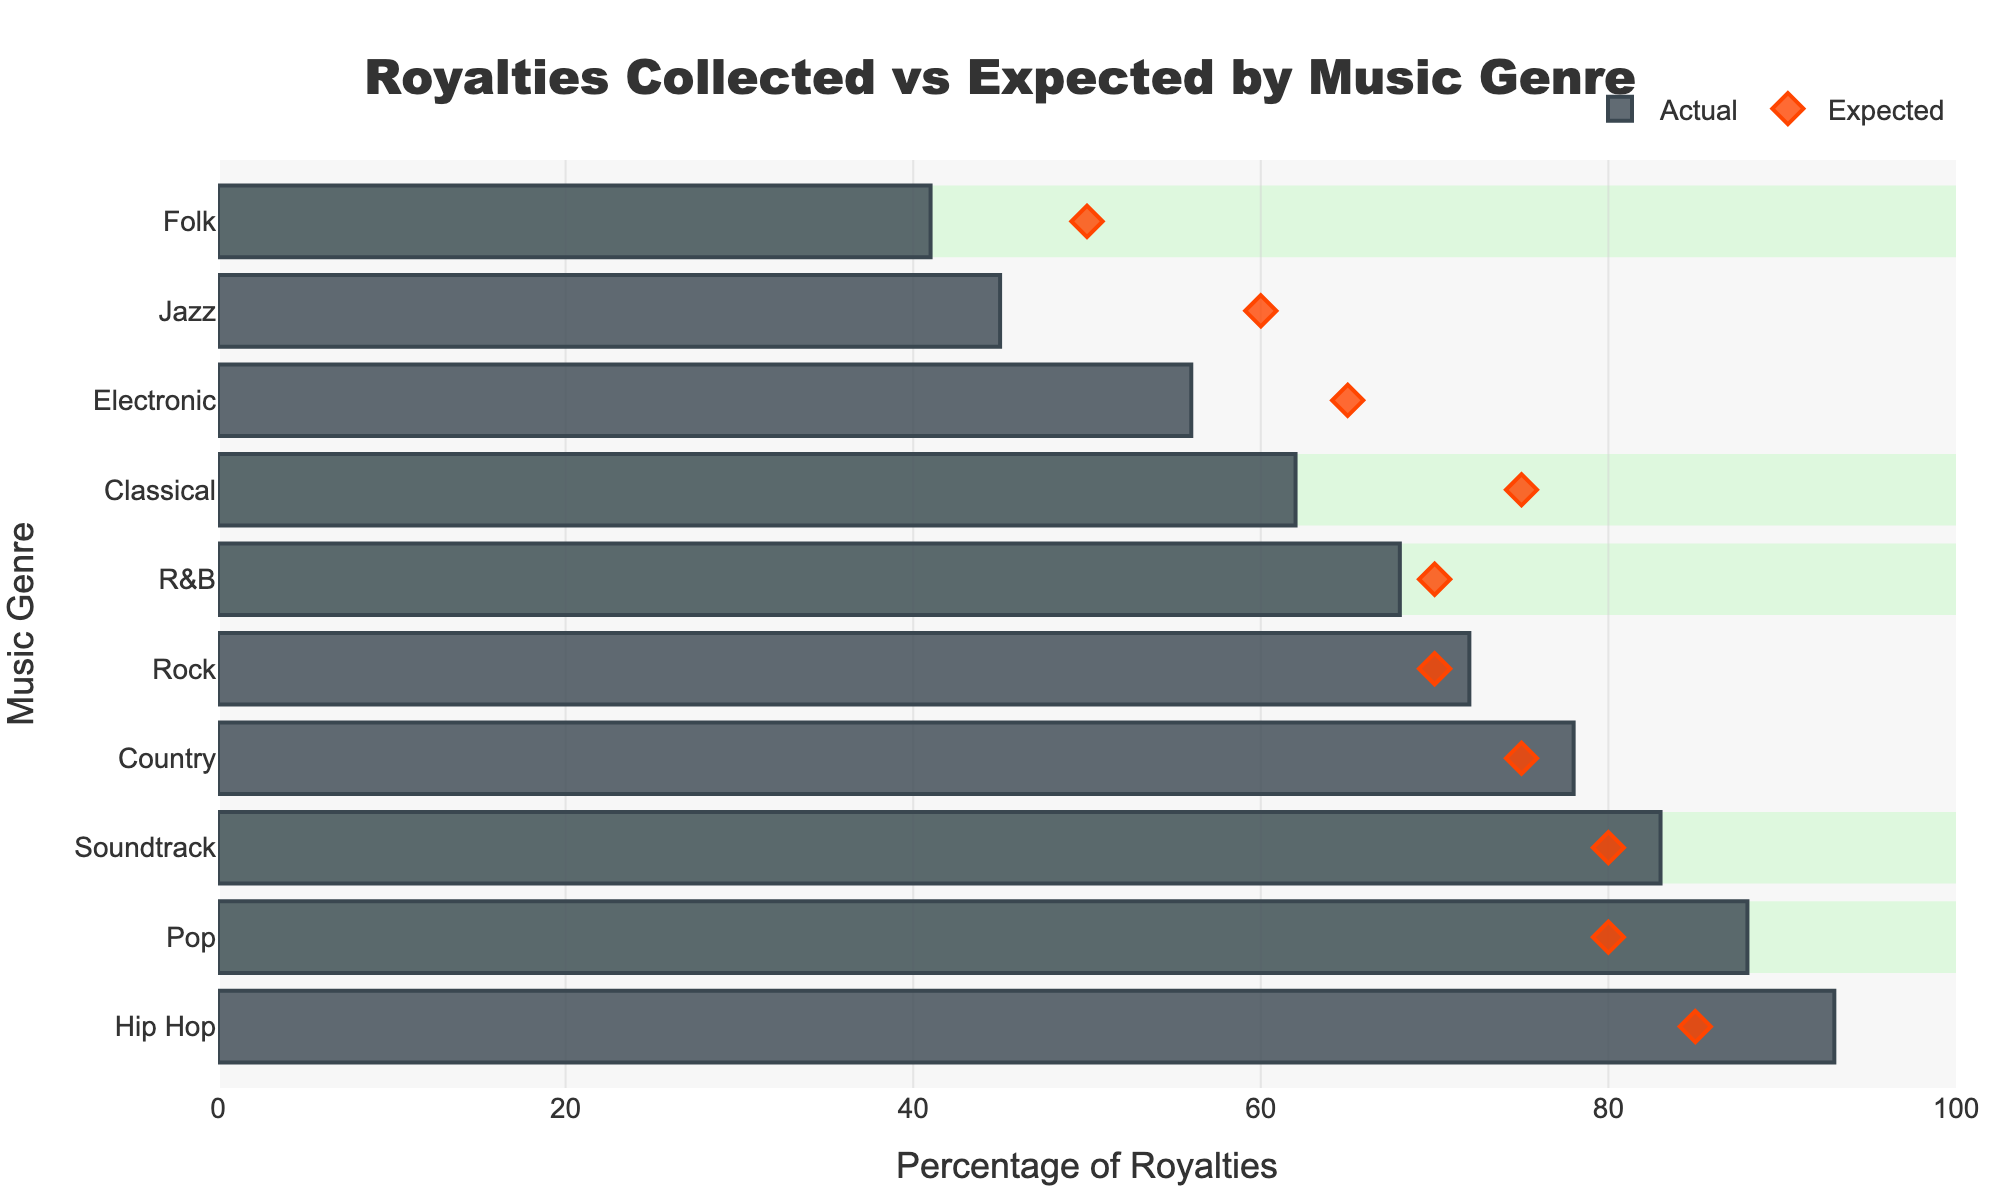What's the main title of the figure? The title is placed at the top of the figure and is denoted in large, noticeable text.
Answer: Royalties Collected vs Expected by Music Genre How many music genres are included in this figure? Count the number of different bars (each representing a genre) on the y-axis.
Answer: 10 Which music genre has the highest actual percentage of royalties collected? Look for the longest bar in the 'Actual' category.
Answer: Hip Hop Which music genre fell short of the expected percentage of royalties by the largest margin? Subtract the 'Actual' percentage from the 'Expected' for each genre and identify the maximum difference. Folk (Expected 50 - Actual 41) = 9.
Answer: Jazz What is the actual percentage of royalties collected for Rock music? Locate the 'Rock' bar and read the corresponding 'Actual' percentage value.
Answer: 72 What color represents the 'Expected' percentage markers? Look for the color of the diamond-shaped markers on the figure.
Answer: Orange Which genres performed as expected or better in terms of royalties? Identify genres where the 'Actual' percentage bar is equal to or longer than the 'Expected' diamond marker.
Answer: Pop, Rock, Hip Hop, Country, Soundtrack In how many genres did the actual royalties exceed the expected royalties? Count the number of genres where the 'Actual' bar is longer than the 'Expected' marker.
Answer: 5 What is the difference in the actual collected percentages between Classical and Electronic music? Subtract the 'Actual' percentage of Electronic from Classical. Classical 62% - Electronic 56% = 6%.
Answer: 6 Which genre shows exactly the same percentage for Actual and Expected royalties? Identify any genre where the length of the 'Actual' bar and position of the 'Expected' marker are the same.
Answer: None 